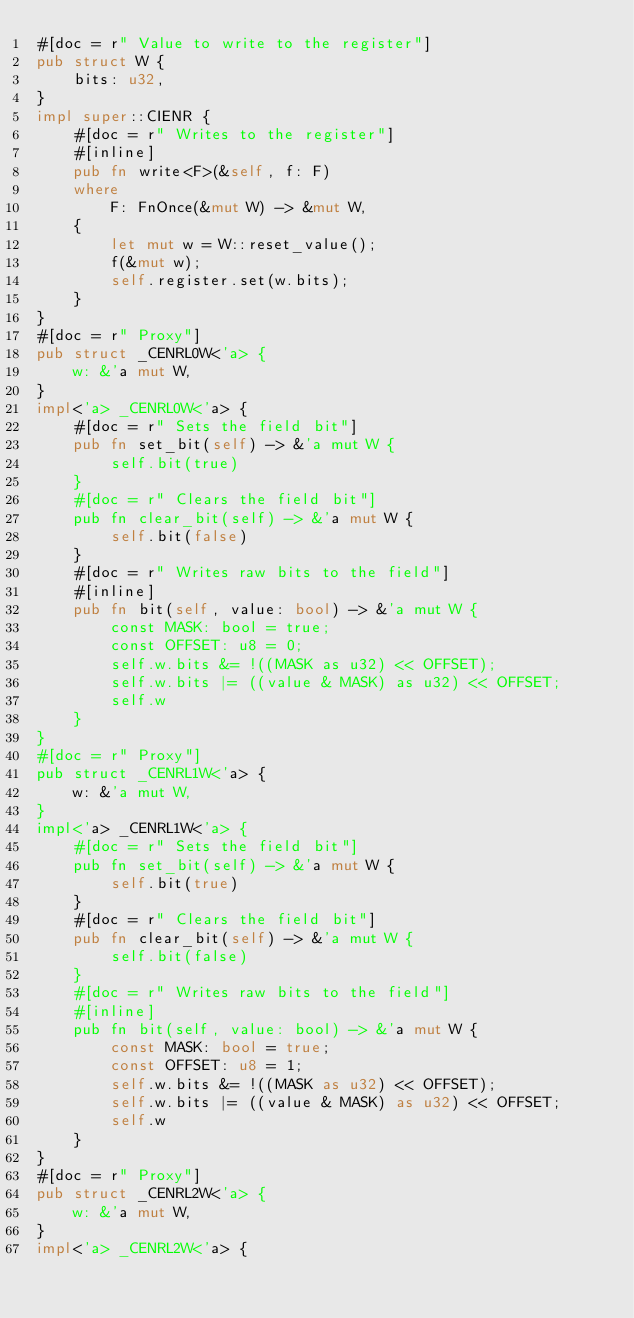<code> <loc_0><loc_0><loc_500><loc_500><_Rust_>#[doc = r" Value to write to the register"]
pub struct W {
    bits: u32,
}
impl super::CIENR {
    #[doc = r" Writes to the register"]
    #[inline]
    pub fn write<F>(&self, f: F)
    where
        F: FnOnce(&mut W) -> &mut W,
    {
        let mut w = W::reset_value();
        f(&mut w);
        self.register.set(w.bits);
    }
}
#[doc = r" Proxy"]
pub struct _CENRL0W<'a> {
    w: &'a mut W,
}
impl<'a> _CENRL0W<'a> {
    #[doc = r" Sets the field bit"]
    pub fn set_bit(self) -> &'a mut W {
        self.bit(true)
    }
    #[doc = r" Clears the field bit"]
    pub fn clear_bit(self) -> &'a mut W {
        self.bit(false)
    }
    #[doc = r" Writes raw bits to the field"]
    #[inline]
    pub fn bit(self, value: bool) -> &'a mut W {
        const MASK: bool = true;
        const OFFSET: u8 = 0;
        self.w.bits &= !((MASK as u32) << OFFSET);
        self.w.bits |= ((value & MASK) as u32) << OFFSET;
        self.w
    }
}
#[doc = r" Proxy"]
pub struct _CENRL1W<'a> {
    w: &'a mut W,
}
impl<'a> _CENRL1W<'a> {
    #[doc = r" Sets the field bit"]
    pub fn set_bit(self) -> &'a mut W {
        self.bit(true)
    }
    #[doc = r" Clears the field bit"]
    pub fn clear_bit(self) -> &'a mut W {
        self.bit(false)
    }
    #[doc = r" Writes raw bits to the field"]
    #[inline]
    pub fn bit(self, value: bool) -> &'a mut W {
        const MASK: bool = true;
        const OFFSET: u8 = 1;
        self.w.bits &= !((MASK as u32) << OFFSET);
        self.w.bits |= ((value & MASK) as u32) << OFFSET;
        self.w
    }
}
#[doc = r" Proxy"]
pub struct _CENRL2W<'a> {
    w: &'a mut W,
}
impl<'a> _CENRL2W<'a> {</code> 